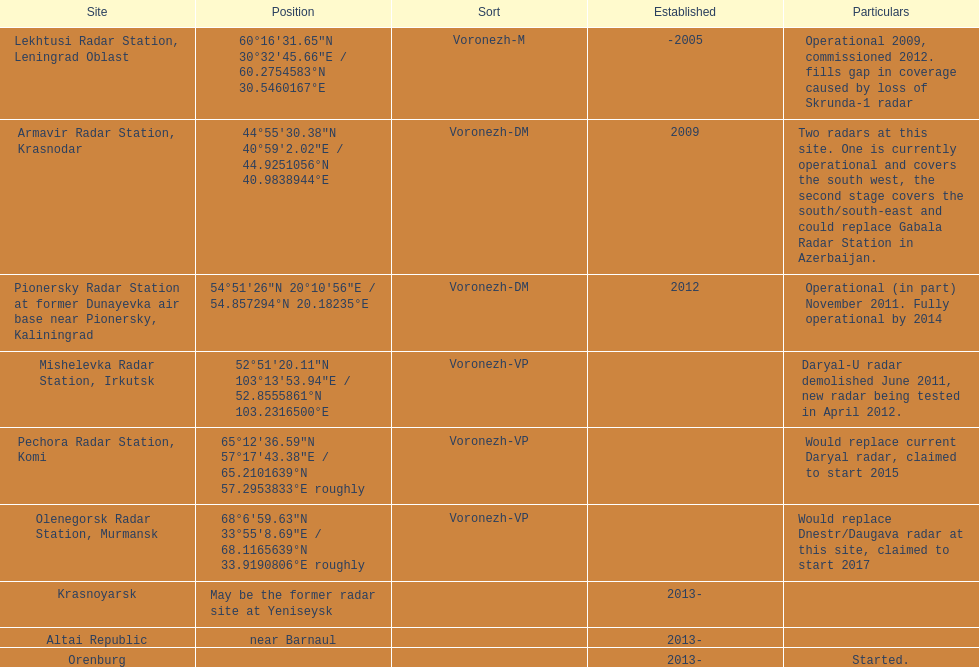When was the top created in terms of year? -2005. 